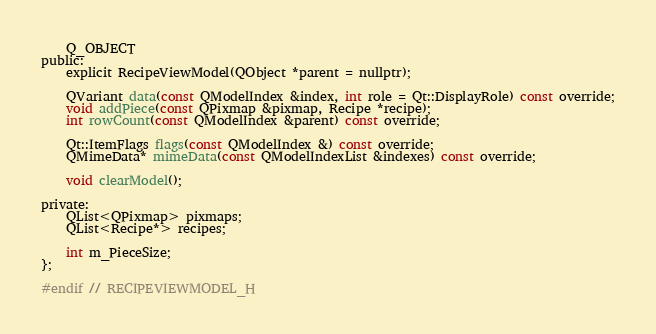Convert code to text. <code><loc_0><loc_0><loc_500><loc_500><_C_>    Q_OBJECT
public:
    explicit RecipeViewModel(QObject *parent = nullptr);

    QVariant data(const QModelIndex &index, int role = Qt::DisplayRole) const override;
    void addPiece(const QPixmap &pixmap, Recipe *recipe);
    int rowCount(const QModelIndex &parent) const override;

    Qt::ItemFlags flags(const QModelIndex &) const override;
    QMimeData* mimeData(const QModelIndexList &indexes) const override;

    void clearModel();

private:
    QList<QPixmap> pixmaps;
    QList<Recipe*> recipes;

    int m_PieceSize;
};

#endif // RECIPEVIEWMODEL_H
</code> 